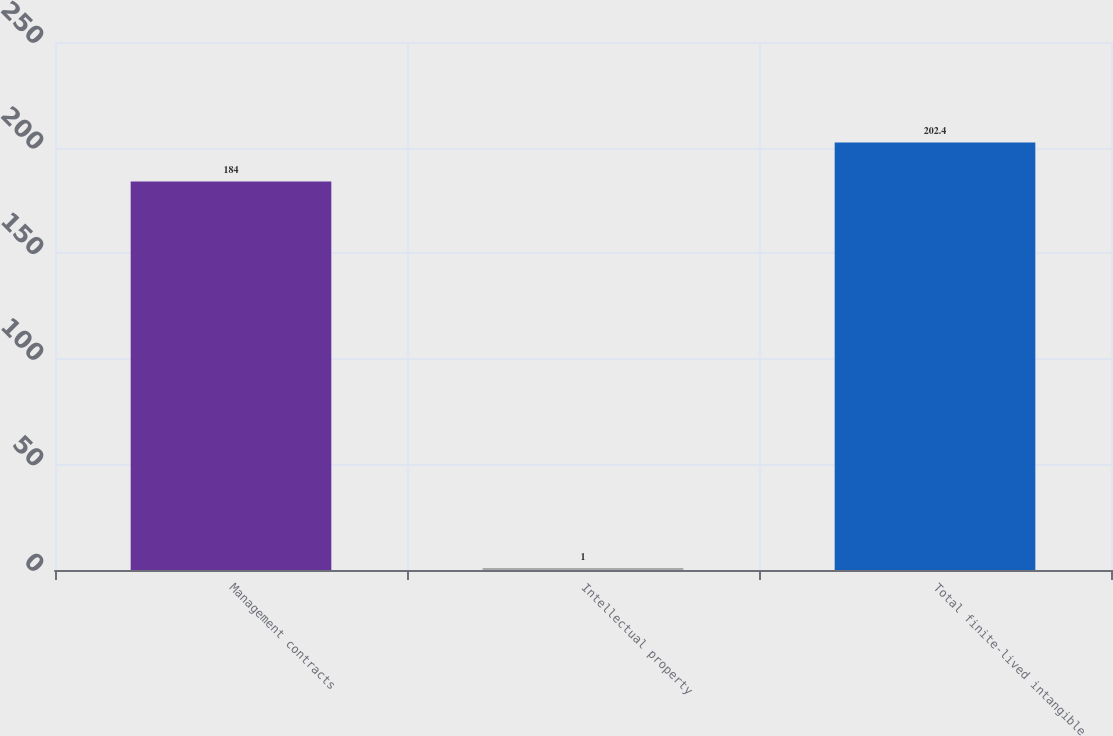Convert chart to OTSL. <chart><loc_0><loc_0><loc_500><loc_500><bar_chart><fcel>Management contracts<fcel>Intellectual property<fcel>Total finite-lived intangible<nl><fcel>184<fcel>1<fcel>202.4<nl></chart> 